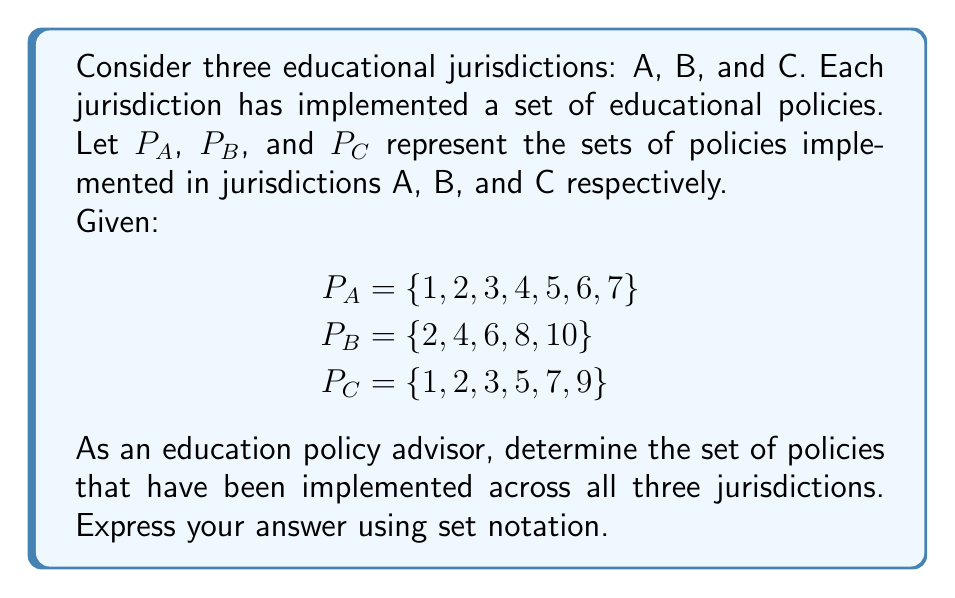Can you solve this math problem? To solve this problem, we need to find the intersection of the three sets $P_A$, $P_B$, and $P_C$. The intersection of these sets will give us the policies that are common to all three jurisdictions.

Let's approach this step-by-step:

1) First, we can identify the intersection of $P_A$ and $P_B$:
   $P_A \cap P_B = \{2, 4, 6\}$

2) Now, we need to find the intersection of this result with $P_C$:
   $(P_A \cap P_B) \cap P_C$

3) Looking at the elements in $P_C$, we can see that only policy 2 is present in all three sets.

4) Therefore, the final intersection is:
   $P_A \cap P_B \cap P_C = \{2\}$

This result indicates that policy 2 is the only policy implemented across all three educational jurisdictions. As an education policy advisor, this information could be valuable in understanding which policies have achieved widespread adoption and might be worth studying for their successful implementation strategies.
Answer: $P_A \cap P_B \cap P_C = \{2\}$ 